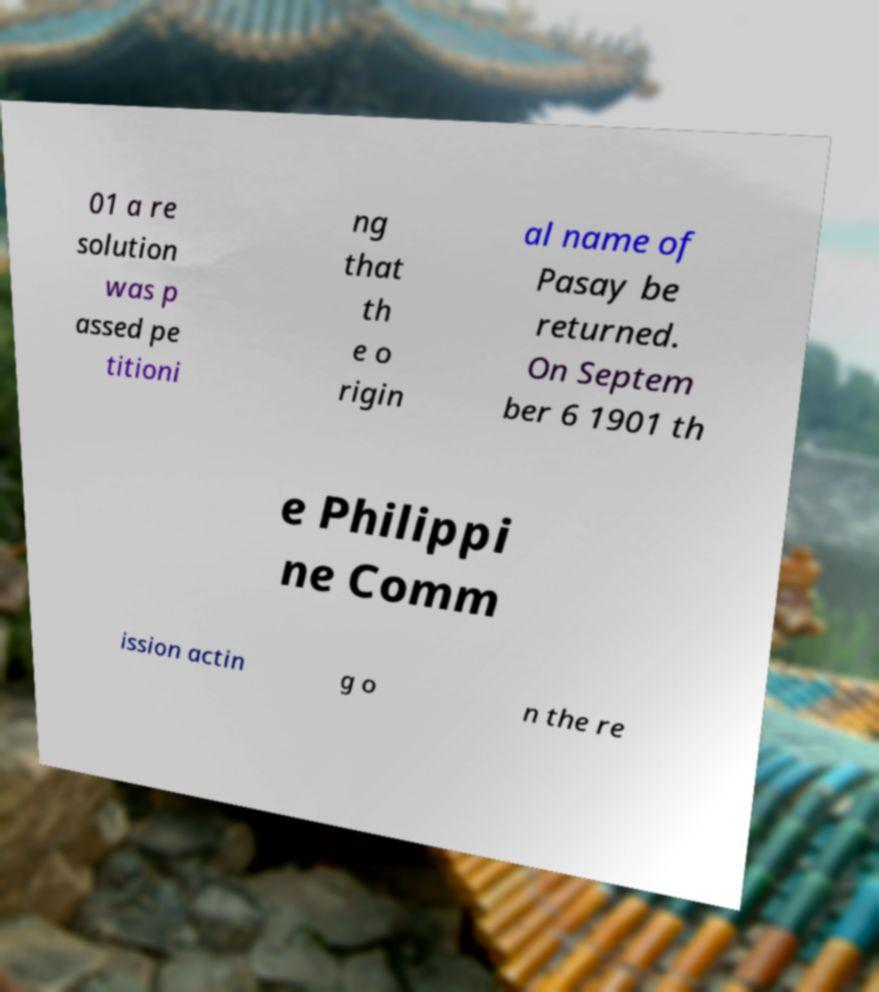Can you read and provide the text displayed in the image?This photo seems to have some interesting text. Can you extract and type it out for me? 01 a re solution was p assed pe titioni ng that th e o rigin al name of Pasay be returned. On Septem ber 6 1901 th e Philippi ne Comm ission actin g o n the re 